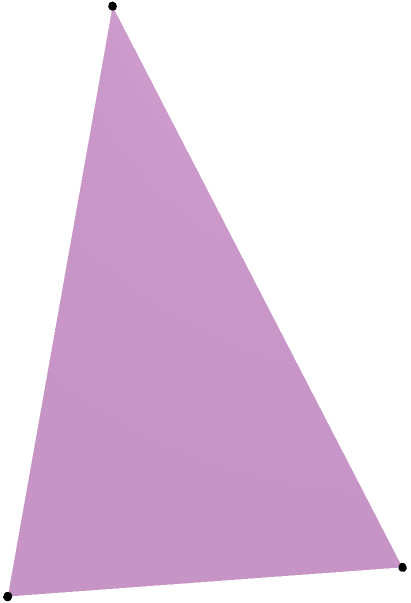For a Broadway production, you're designing a pyramidal set piece. The base is a right triangle with sides 3m and 4m, and the height of the pyramid is 5m. Calculate the lateral surface area of this set piece, excluding the base. Round your answer to the nearest square meter. Let's approach this step-by-step:

1) First, we need to find the length of the hypotenuse of the base triangle using the Pythagorean theorem:
   $$c^2 = 3^2 + 4^2 = 9 + 16 = 25$$
   $$c = \sqrt{25} = 5\text{ m}$$

2) Now, we have a pyramid with a triangular base (3m, 4m, 5m) and height 5m.

3) To find the lateral surface area, we need to calculate the area of three triangular faces and sum them up.

4) For each face, we can use the formula: $A = \frac{1}{2} \times \text{base} \times \text{height}$

5) We need to find the height of each triangular face. We can do this using the Pythagorean theorem again:
   For the face with 3m base: $h_1^2 = 5^2 + (\frac{3}{2})^2 = 25 + 2.25 = 27.25$, so $h_1 = \sqrt{27.25} \approx 5.22\text{ m}$
   For the face with 4m base: $h_2^2 = 5^2 + 2^2 = 25 + 4 = 29$, so $h_2 = \sqrt{29} \approx 5.39\text{ m}$
   For the face with 5m base: $h_3^2 = 5^2 + (\frac{5}{2})^2 = 25 + 6.25 = 31.25$, so $h_3 = \sqrt{31.25} \approx 5.59\text{ m}$

6) Now we can calculate the areas:
   $A_1 = \frac{1}{2} \times 3 \times 5.22 \approx 7.83\text{ m}^2$
   $A_2 = \frac{1}{2} \times 4 \times 5.39 \approx 10.78\text{ m}^2$
   $A_3 = \frac{1}{2} \times 5 \times 5.59 \approx 13.98\text{ m}^2$

7) The total lateral surface area is the sum of these three areas:
   $A_{total} = 7.83 + 10.78 + 13.98 = 32.59\text{ m}^2$

8) Rounding to the nearest square meter, we get 33 m².
Answer: 33 m² 